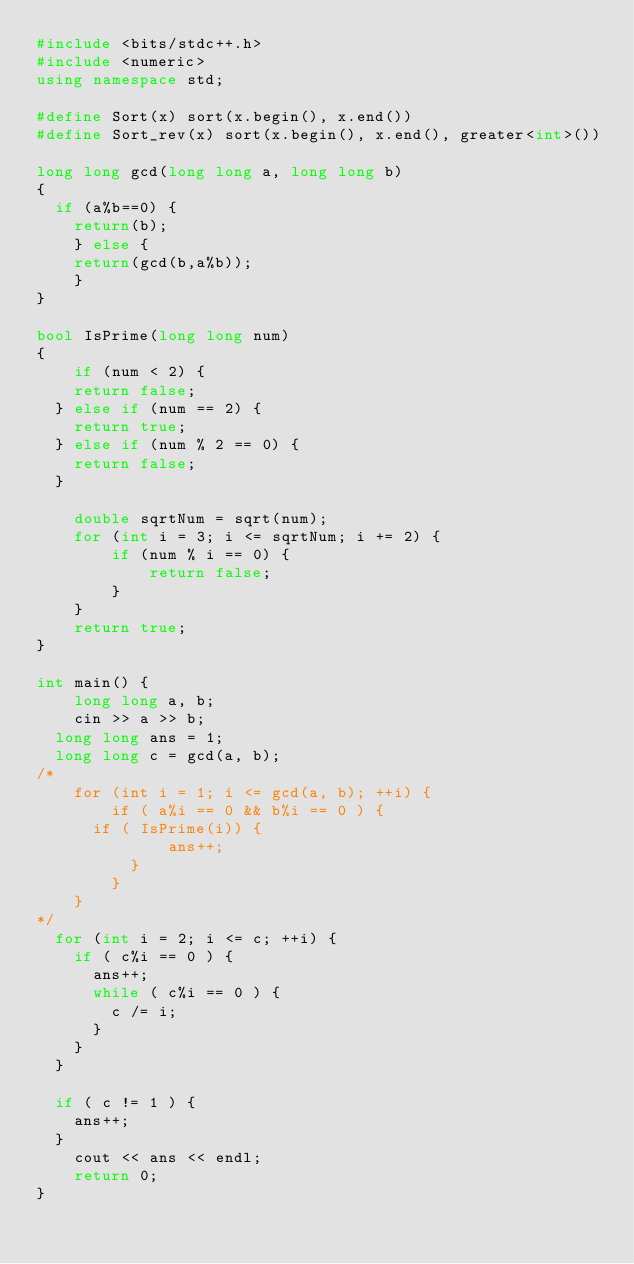Convert code to text. <code><loc_0><loc_0><loc_500><loc_500><_C++_>#include <bits/stdc++.h>
#include <numeric>
using namespace std;

#define Sort(x) sort(x.begin(), x.end())
#define Sort_rev(x) sort(x.begin(), x.end(), greater<int>())

long long gcd(long long a, long long b)
{
	if (a%b==0) {
		return(b);
    } else {
		return(gcd(b,a%b));
    }
}

bool IsPrime(long long num)
{
    if (num < 2) {
		return false;
	} else if (num == 2) {
		return true;
	} else if (num % 2 == 0) {
		return false;
	}

    double sqrtNum = sqrt(num);
    for (int i = 3; i <= sqrtNum; i += 2) {
        if (num % i == 0) {
            return false;
        }
    }
    return true;
}

int main() {
    long long a, b;
    cin >> a >> b;
	long long ans = 1;
	long long c = gcd(a, b);
/*
    for (int i = 1; i <= gcd(a, b); ++i) {
        if ( a%i == 0 && b%i == 0 ) {
			if ( IsPrime(i)) {
	            ans++;
	        }
        }
    }
*/
	for (int i = 2; i <= c; ++i) {
		if ( c%i == 0 ) {
			ans++;
			while ( c%i == 0 ) {
				c /= i;
			}
		}
	}

	if ( c != 1 ) {
		ans++;
	}
    cout << ans << endl;
    return 0;
}
</code> 